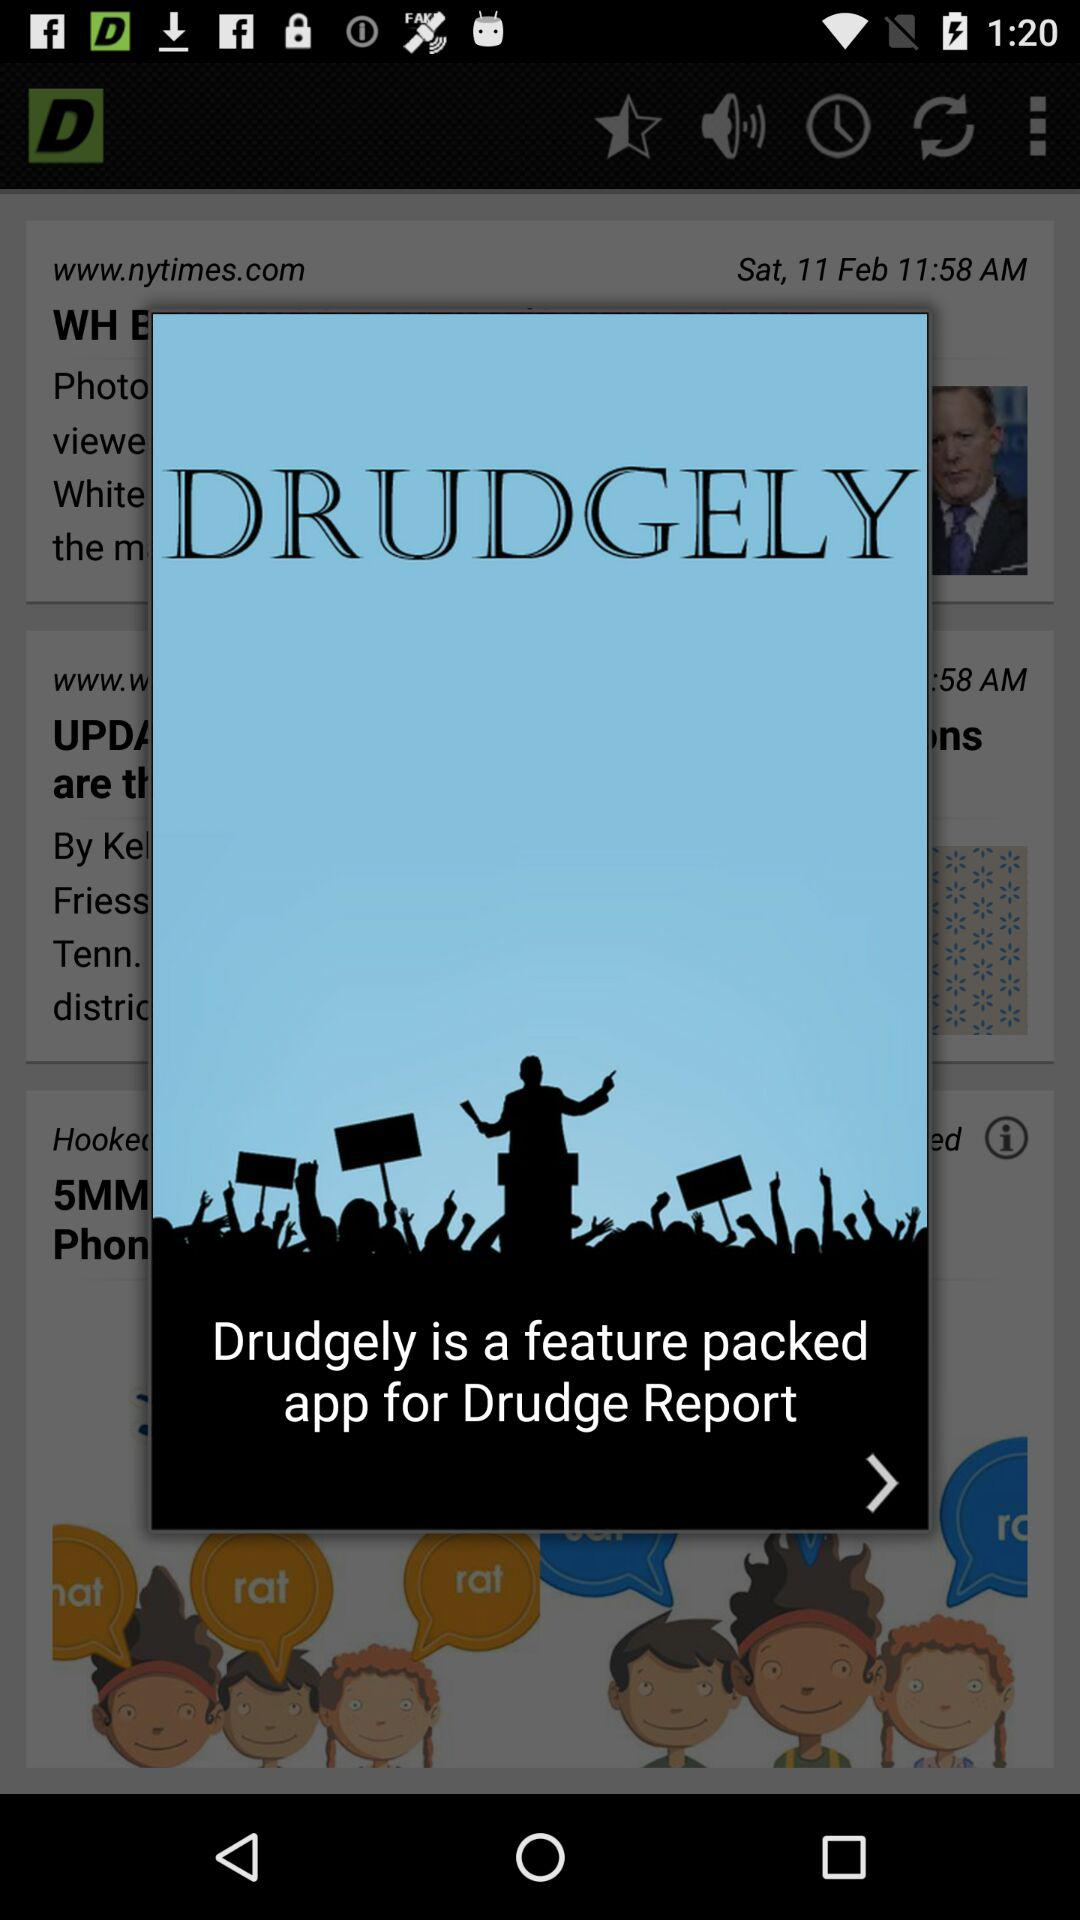When was the "Drudge Report" posted?
When the provided information is insufficient, respond with <no answer>. <no answer> 